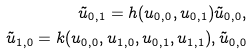<formula> <loc_0><loc_0><loc_500><loc_500>\tilde { u } _ { 0 , 1 } = h ( u _ { 0 , 0 } , u _ { 0 , 1 } ) \tilde { u } _ { 0 , 0 } , \\ \tilde { u } _ { 1 , 0 } = k ( u _ { 0 , 0 } , u _ { 1 , 0 } , u _ { 0 , 1 } , u _ { 1 , 1 } ) , \tilde { u } _ { 0 , 0 }</formula> 